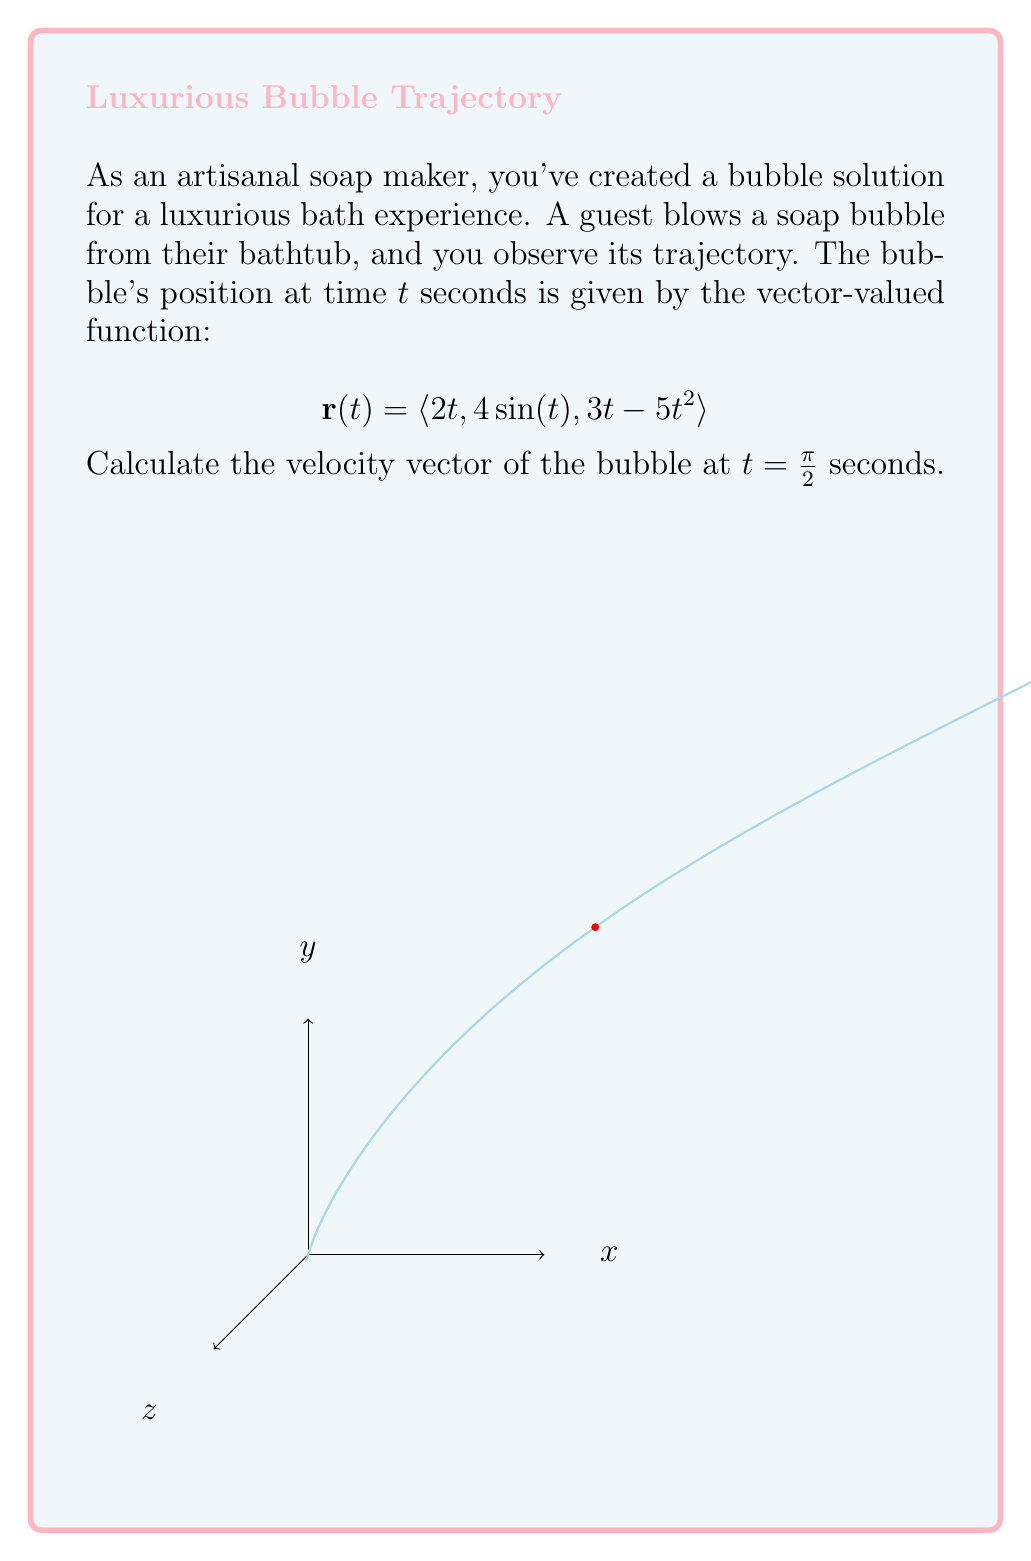Help me with this question. Let's approach this step-by-step:

1) The velocity vector is the derivative of the position vector with respect to time. So, we need to calculate $\mathbf{r}'(t)$.

2) Let's differentiate each component of $\mathbf{r}(t)$:
   
   $\frac{d}{dt}(2t) = 2$
   
   $\frac{d}{dt}(4\sin(t)) = 4\cos(t)$
   
   $\frac{d}{dt}(3t - 5t^2) = 3 - 10t$

3) Therefore, the velocity vector is:

   $$\mathbf{r}'(t) = \langle 2, 4\cos(t), 3 - 10t \rangle$$

4) We need to evaluate this at $t = \frac{\pi}{2}$:

   $$\mathbf{r}'(\frac{\pi}{2}) = \langle 2, 4\cos(\frac{\pi}{2}), 3 - 10(\frac{\pi}{2}) \rangle$$

5) Simplify:
   - $\cos(\frac{\pi}{2}) = 0$
   - $3 - 10(\frac{\pi}{2}) = 3 - 5\pi$

6) Therefore, the final velocity vector is:

   $$\mathbf{r}'(\frac{\pi}{2}) = \langle 2, 0, 3 - 5\pi \rangle$$

This vector represents the instantaneous velocity of the soap bubble at $t = \frac{\pi}{2}$ seconds.
Answer: $\langle 2, 0, 3 - 5\pi \rangle$ 